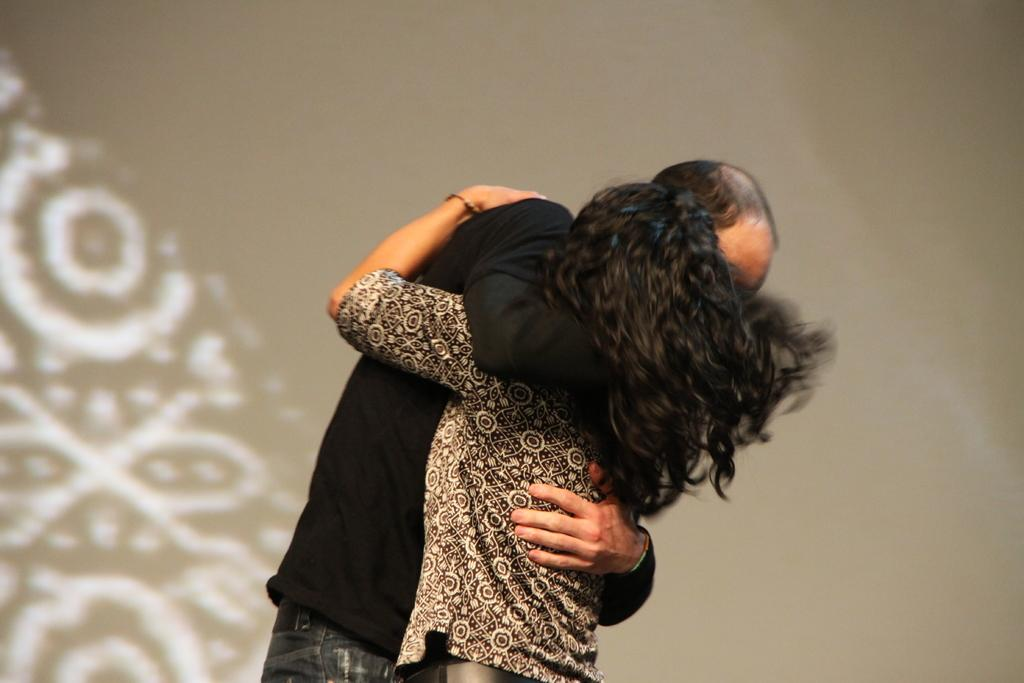How many people are in the image? There are two persons in the image. What are the two persons doing in the image? The two persons are standing and hugging each other. What can be seen in the background of the image? There is a wall in the background of the image. What type of popcorn is being shared between the two persons in the image? There is no popcorn present in the image; the two persons are hugging each other. How much does the dime on the wall cost in the image? There is no dime present on the wall in the image. 